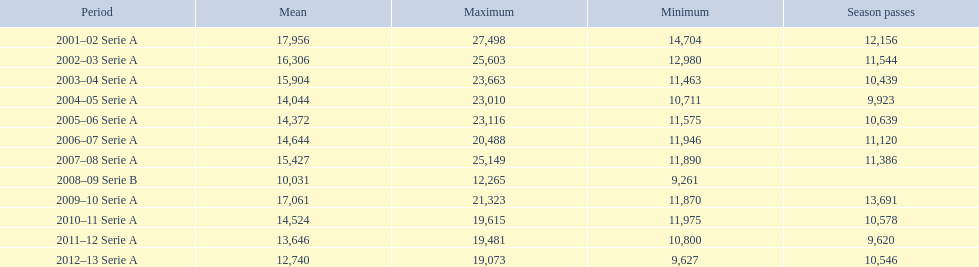What seasons were played at the stadio ennio tardini 2001–02 Serie A, 2002–03 Serie A, 2003–04 Serie A, 2004–05 Serie A, 2005–06 Serie A, 2006–07 Serie A, 2007–08 Serie A, 2008–09 Serie B, 2009–10 Serie A, 2010–11 Serie A, 2011–12 Serie A, 2012–13 Serie A. Which of these seasons had season tickets? 2001–02 Serie A, 2002–03 Serie A, 2003–04 Serie A, 2004–05 Serie A, 2005–06 Serie A, 2006–07 Serie A, 2007–08 Serie A, 2009–10 Serie A, 2010–11 Serie A, 2011–12 Serie A, 2012–13 Serie A. How many season tickets did the 2007-08 season have? 11,386. 